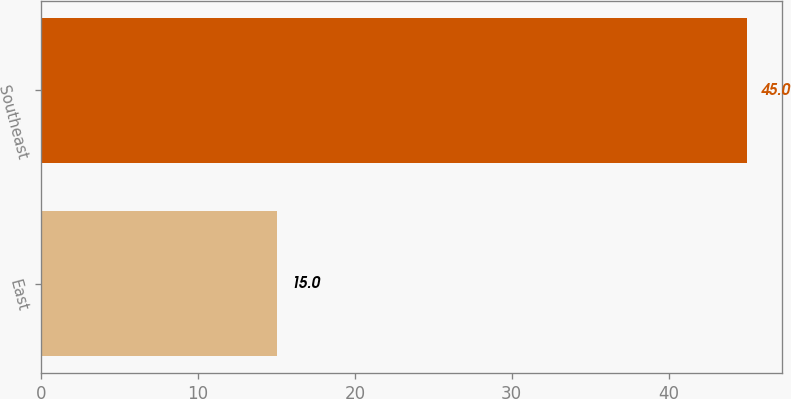<chart> <loc_0><loc_0><loc_500><loc_500><bar_chart><fcel>East<fcel>Southeast<nl><fcel>15<fcel>45<nl></chart> 